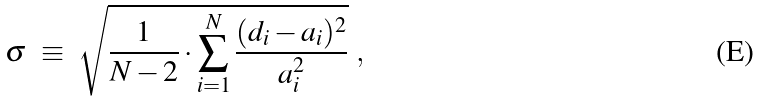<formula> <loc_0><loc_0><loc_500><loc_500>\sigma \ \equiv \ \sqrt { \frac { 1 } { N - 2 } \cdot \sum _ { i = 1 } ^ { N } \frac { ( d _ { i } - a _ { i } ) ^ { 2 } } { a _ { i } ^ { 2 } } } \ ,</formula> 